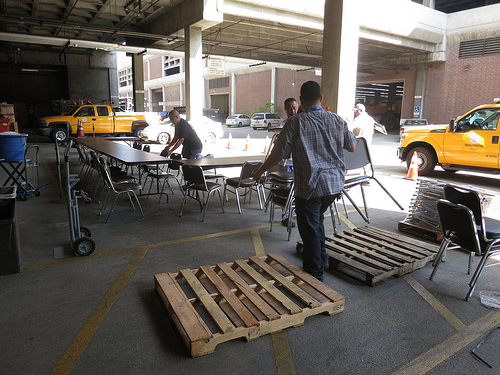<image>
Can you confirm if the man is in front of the table? Yes. The man is positioned in front of the table, appearing closer to the camera viewpoint. 